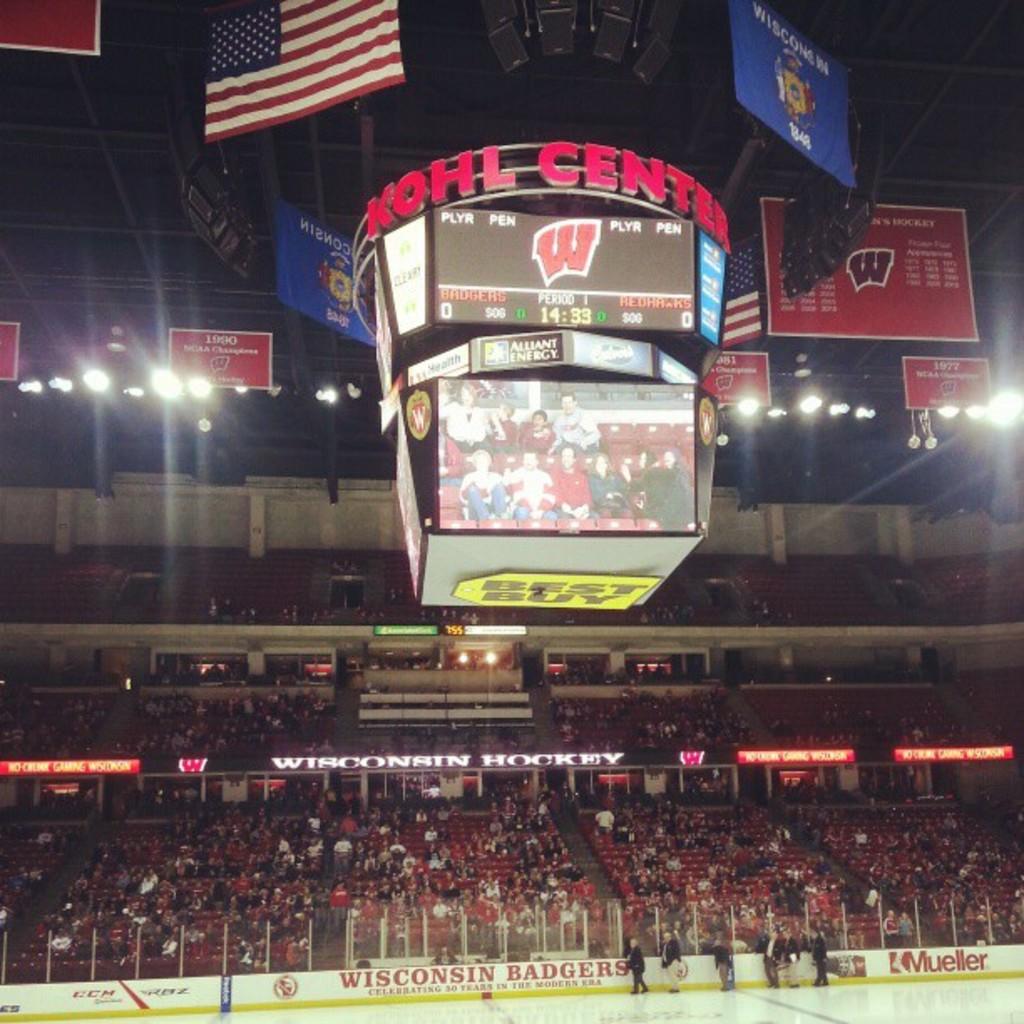In which state is the hockey game being played?
Your answer should be compact. Wisconsin. Underneath the scoreboard what company in yellow is being advertised?
Offer a very short reply. Best buy. 